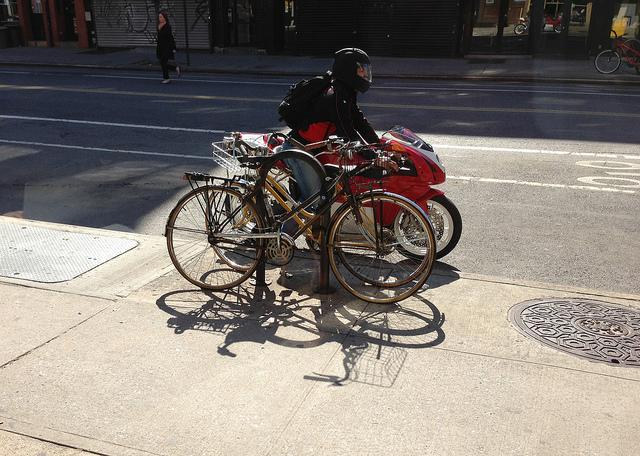In which lane does the person in the black helmet ride?

Choices:
A) dirt lane
B) right lane
C) median lane
D) bike lane right lane 